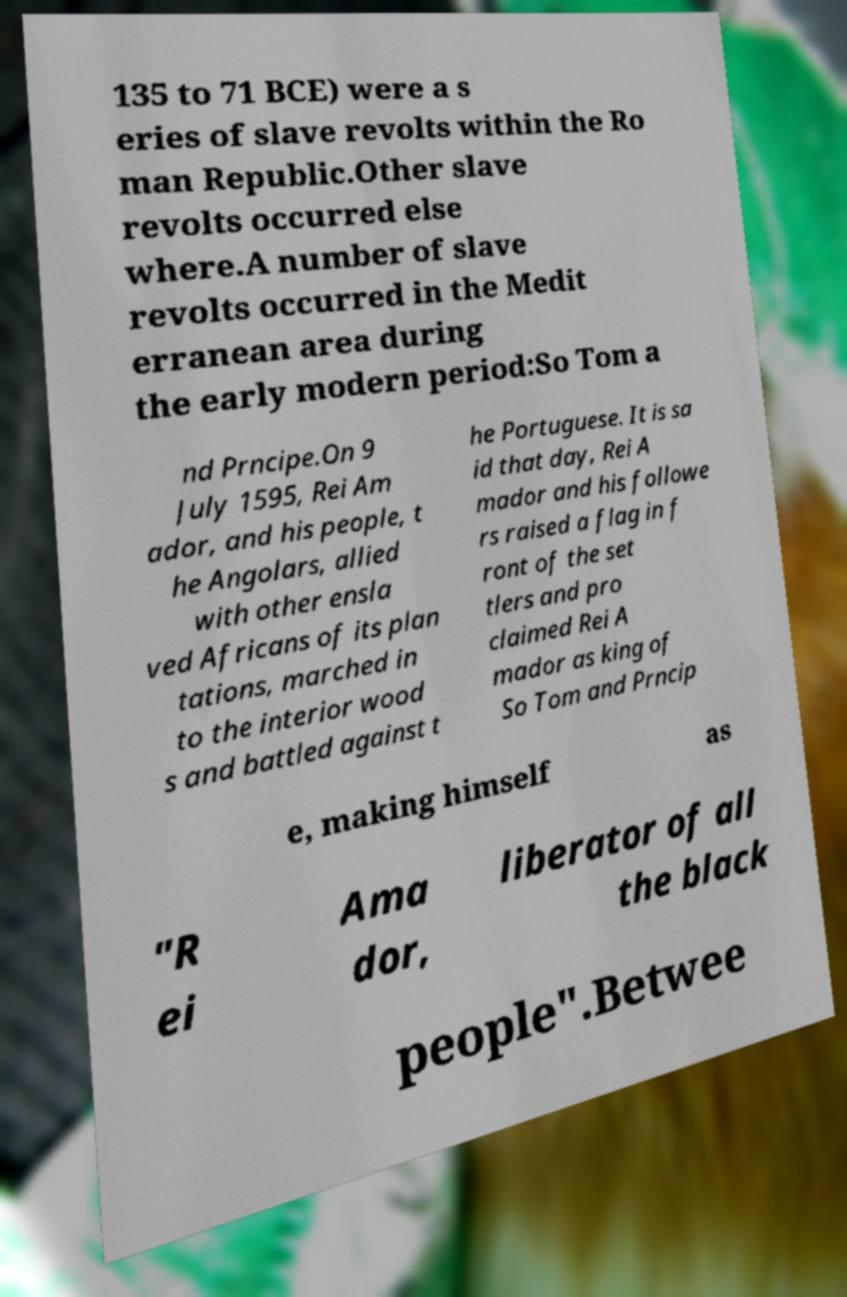Please read and relay the text visible in this image. What does it say? 135 to 71 BCE) were a s eries of slave revolts within the Ro man Republic.Other slave revolts occurred else where.A number of slave revolts occurred in the Medit erranean area during the early modern period:So Tom a nd Prncipe.On 9 July 1595, Rei Am ador, and his people, t he Angolars, allied with other ensla ved Africans of its plan tations, marched in to the interior wood s and battled against t he Portuguese. It is sa id that day, Rei A mador and his followe rs raised a flag in f ront of the set tlers and pro claimed Rei A mador as king of So Tom and Prncip e, making himself as "R ei Ama dor, liberator of all the black people".Betwee 